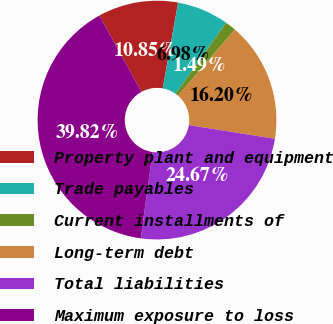Convert chart. <chart><loc_0><loc_0><loc_500><loc_500><pie_chart><fcel>Property plant and equipment<fcel>Trade payables<fcel>Current installments of<fcel>Long-term debt<fcel>Total liabilities<fcel>Maximum exposure to loss<nl><fcel>10.85%<fcel>6.98%<fcel>1.49%<fcel>16.2%<fcel>24.67%<fcel>39.82%<nl></chart> 